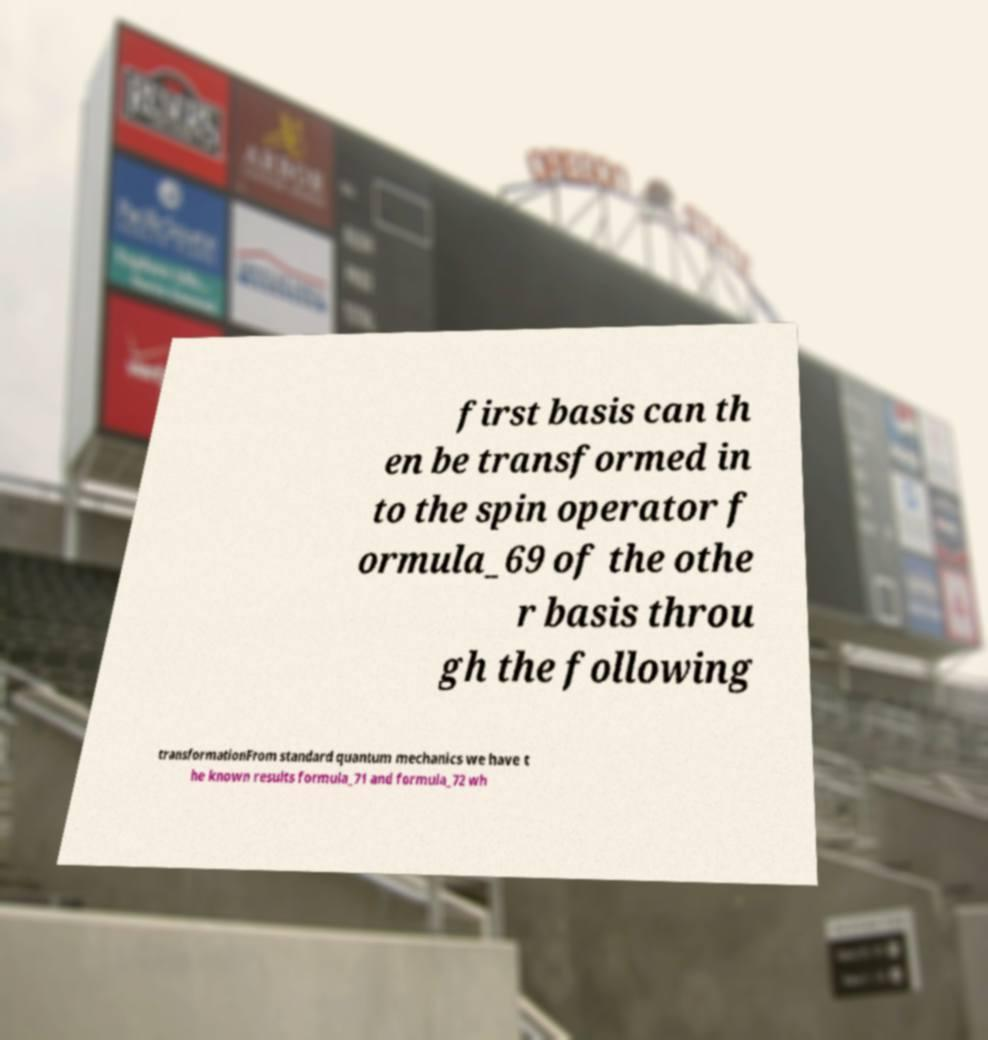Please read and relay the text visible in this image. What does it say? first basis can th en be transformed in to the spin operator f ormula_69 of the othe r basis throu gh the following transformationFrom standard quantum mechanics we have t he known results formula_71 and formula_72 wh 